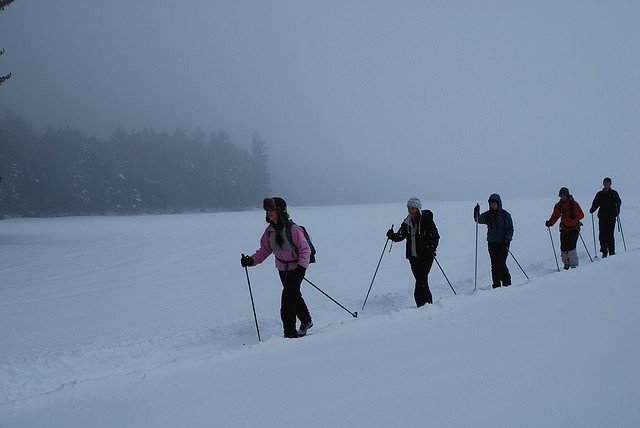Describe the objects in this image and their specific colors. I can see people in black, purple, and darkgray tones, people in black, darkgray, and gray tones, people in black, darkgray, and gray tones, people in black, gray, maroon, and blue tones, and people in black, navy, gray, and darkgray tones in this image. 